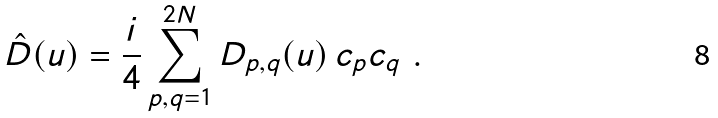Convert formula to latex. <formula><loc_0><loc_0><loc_500><loc_500>\hat { D } ( u ) = \frac { i } 4 \sum _ { p , q = 1 } ^ { 2 N } D _ { p , q } ( u ) \, c _ { p } c _ { q } \ .</formula> 